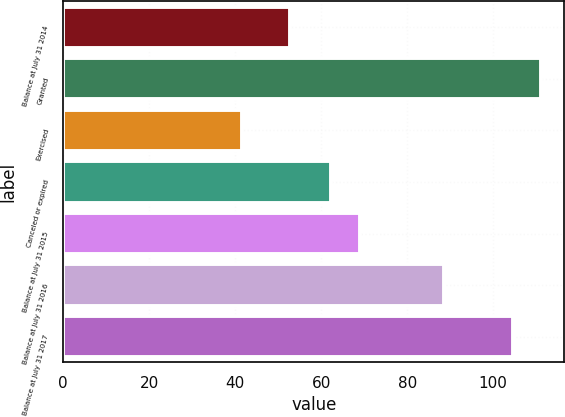Convert chart. <chart><loc_0><loc_0><loc_500><loc_500><bar_chart><fcel>Balance at July 31 2014<fcel>Granted<fcel>Exercised<fcel>Canceled or expired<fcel>Balance at July 31 2015<fcel>Balance at July 31 2016<fcel>Balance at July 31 2017<nl><fcel>52.67<fcel>111.02<fcel>41.65<fcel>62.32<fcel>69.13<fcel>88.55<fcel>104.5<nl></chart> 